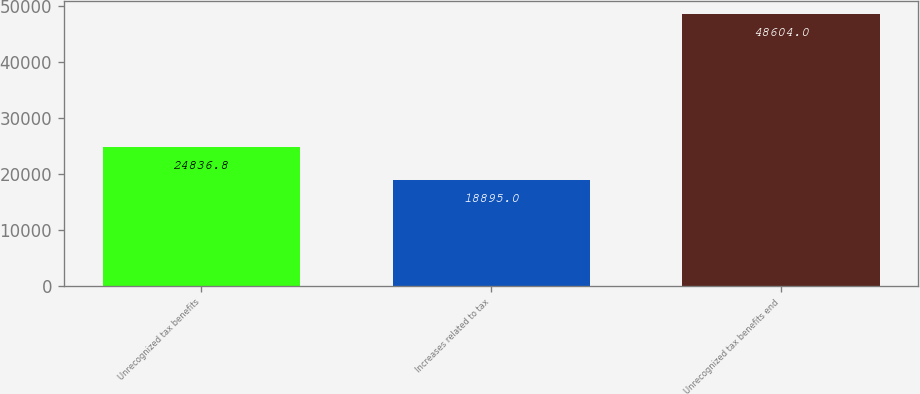Convert chart. <chart><loc_0><loc_0><loc_500><loc_500><bar_chart><fcel>Unrecognized tax benefits<fcel>Increases related to tax<fcel>Unrecognized tax benefits end<nl><fcel>24836.8<fcel>18895<fcel>48604<nl></chart> 